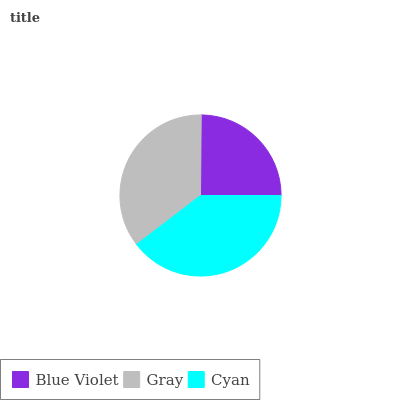Is Blue Violet the minimum?
Answer yes or no. Yes. Is Cyan the maximum?
Answer yes or no. Yes. Is Gray the minimum?
Answer yes or no. No. Is Gray the maximum?
Answer yes or no. No. Is Gray greater than Blue Violet?
Answer yes or no. Yes. Is Blue Violet less than Gray?
Answer yes or no. Yes. Is Blue Violet greater than Gray?
Answer yes or no. No. Is Gray less than Blue Violet?
Answer yes or no. No. Is Gray the high median?
Answer yes or no. Yes. Is Gray the low median?
Answer yes or no. Yes. Is Cyan the high median?
Answer yes or no. No. Is Blue Violet the low median?
Answer yes or no. No. 